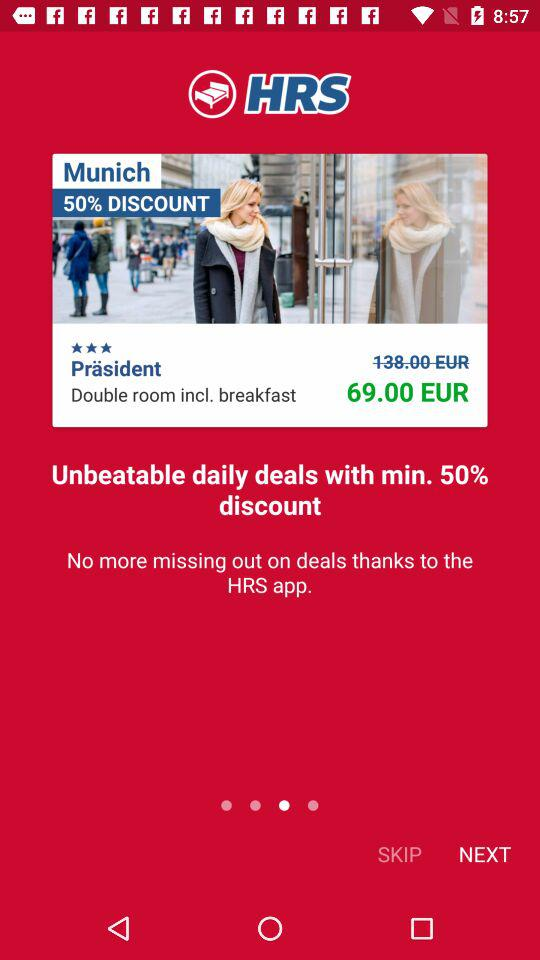What is the name of the application? The name of the application is "HRS". 